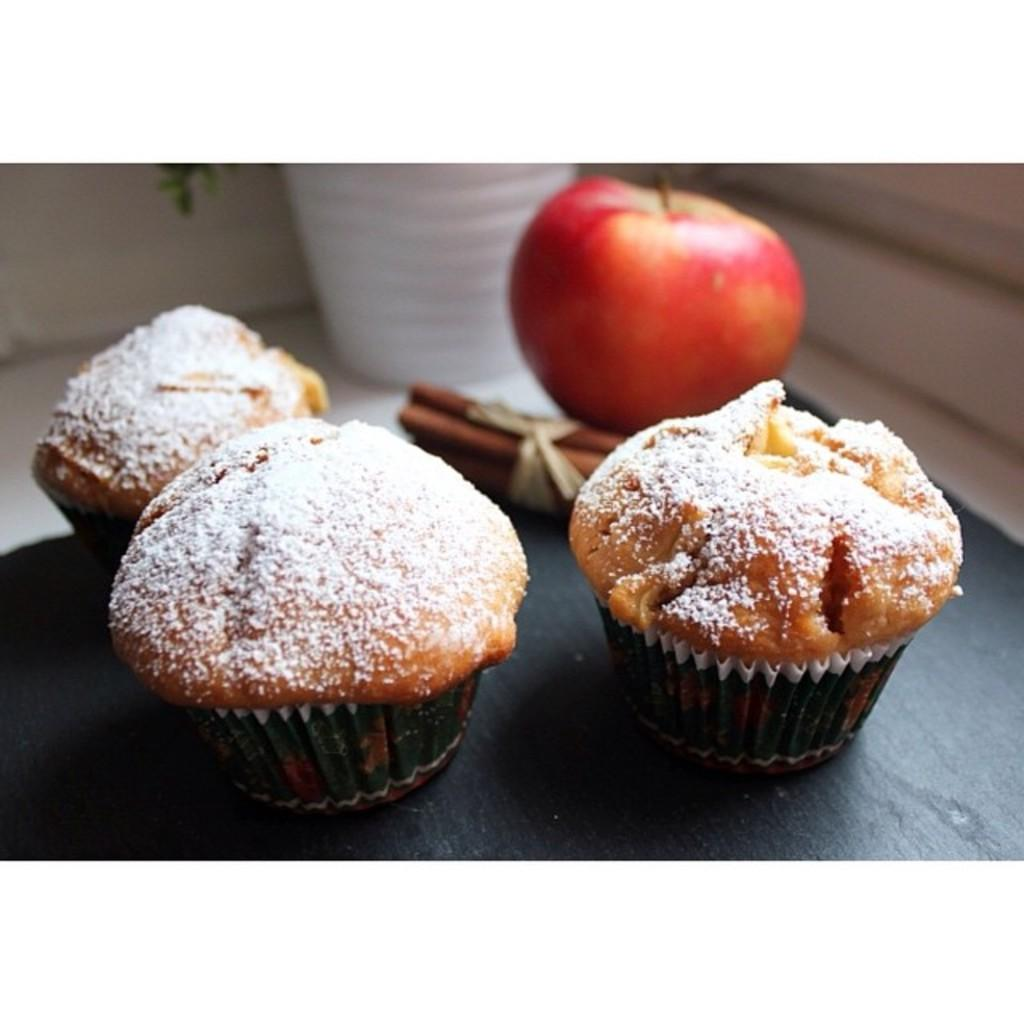What type of food items can be seen in the image? There are cupcakes and an apple in the image. Are there any other objects present in the image? Yes, there are other objects in the image. Where are the food items and objects placed? They are placed on a platform. What can be seen in the background of the image? There is a wall visible in the background of the image. What type of blood can be seen dripping from the cupcakes in the image? There is no blood present in the image; it features cupcakes and an apple placed on a platform. What kind of wave can be seen crashing into the wall in the background of the image? There is no wave present in the image; it features a wall visible in the background. 